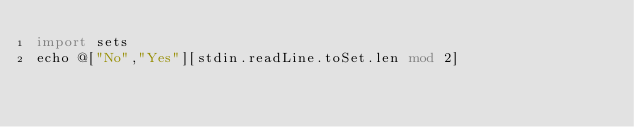<code> <loc_0><loc_0><loc_500><loc_500><_Nim_>import sets
echo @["No","Yes"][stdin.readLine.toSet.len mod 2]</code> 